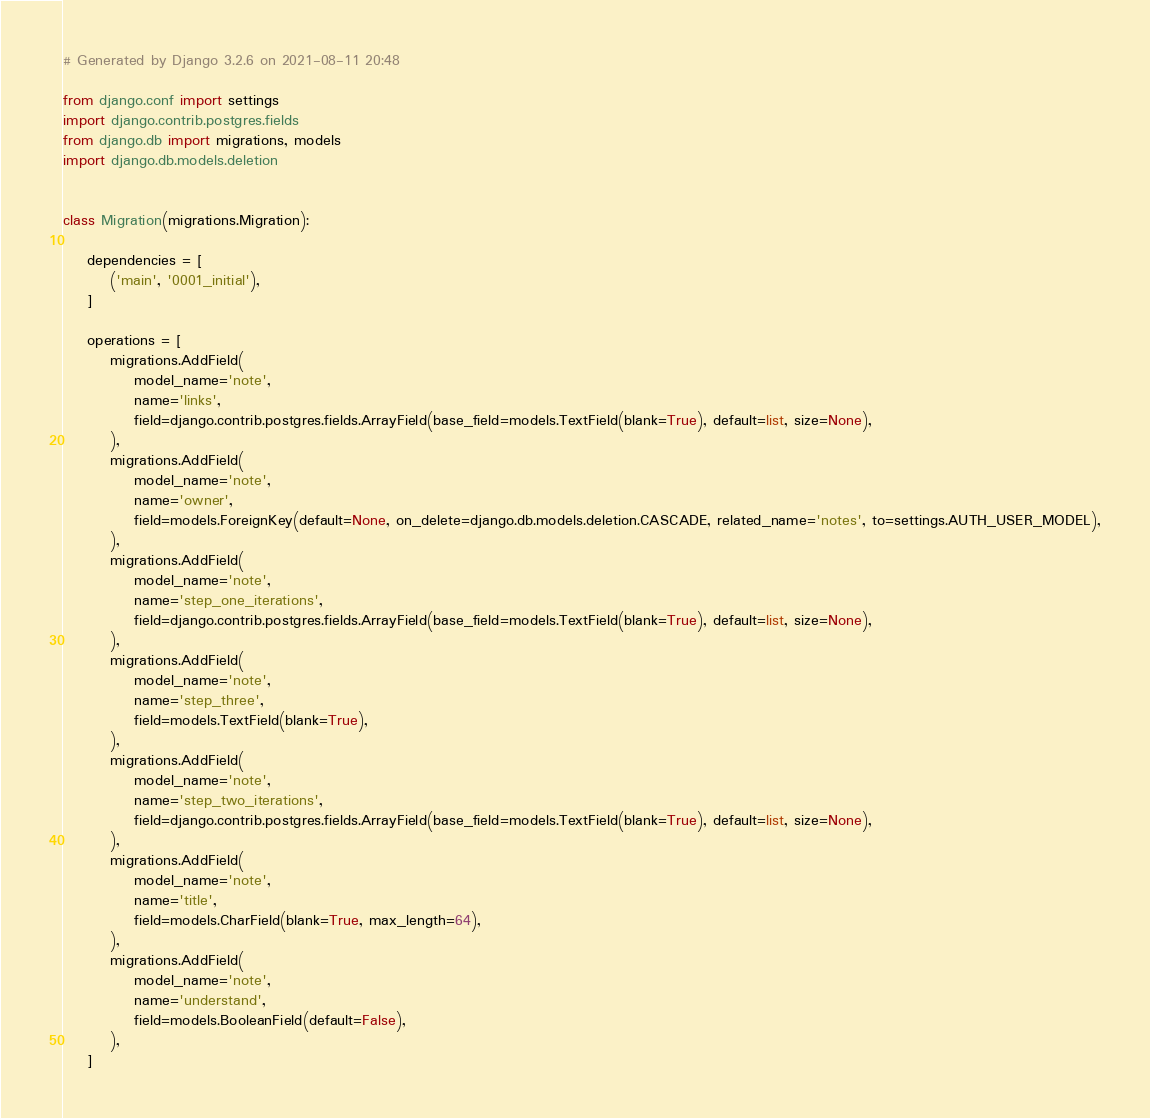Convert code to text. <code><loc_0><loc_0><loc_500><loc_500><_Python_># Generated by Django 3.2.6 on 2021-08-11 20:48

from django.conf import settings
import django.contrib.postgres.fields
from django.db import migrations, models
import django.db.models.deletion


class Migration(migrations.Migration):

    dependencies = [
        ('main', '0001_initial'),
    ]

    operations = [
        migrations.AddField(
            model_name='note',
            name='links',
            field=django.contrib.postgres.fields.ArrayField(base_field=models.TextField(blank=True), default=list, size=None),
        ),
        migrations.AddField(
            model_name='note',
            name='owner',
            field=models.ForeignKey(default=None, on_delete=django.db.models.deletion.CASCADE, related_name='notes', to=settings.AUTH_USER_MODEL),
        ),
        migrations.AddField(
            model_name='note',
            name='step_one_iterations',
            field=django.contrib.postgres.fields.ArrayField(base_field=models.TextField(blank=True), default=list, size=None),
        ),
        migrations.AddField(
            model_name='note',
            name='step_three',
            field=models.TextField(blank=True),
        ),
        migrations.AddField(
            model_name='note',
            name='step_two_iterations',
            field=django.contrib.postgres.fields.ArrayField(base_field=models.TextField(blank=True), default=list, size=None),
        ),
        migrations.AddField(
            model_name='note',
            name='title',
            field=models.CharField(blank=True, max_length=64),
        ),
        migrations.AddField(
            model_name='note',
            name='understand',
            field=models.BooleanField(default=False),
        ),
    ]
</code> 